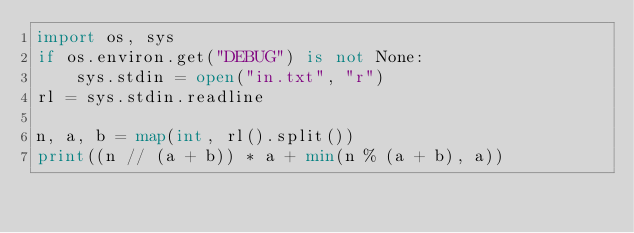<code> <loc_0><loc_0><loc_500><loc_500><_Python_>import os, sys
if os.environ.get("DEBUG") is not None:
    sys.stdin = open("in.txt", "r")
rl = sys.stdin.readline

n, a, b = map(int, rl().split())
print((n // (a + b)) * a + min(n % (a + b), a))</code> 